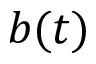Convert formula to latex. <formula><loc_0><loc_0><loc_500><loc_500>b ( t )</formula> 